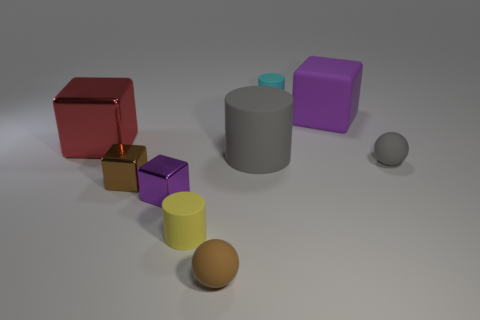There is a tiny cylinder to the left of the small cylinder that is behind the ball that is right of the purple matte object; what is its material?
Keep it short and to the point. Rubber. Is the number of yellow objects that are left of the yellow cylinder greater than the number of red blocks behind the tiny brown metallic block?
Provide a short and direct response. No. How many spheres are either big red objects or tiny cyan rubber objects?
Keep it short and to the point. 0. There is a matte sphere that is in front of the cylinder in front of the small gray rubber ball; how many small yellow matte cylinders are right of it?
Your response must be concise. 0. What is the material of the thing that is the same color as the large rubber cube?
Your answer should be very brief. Metal. Are there more small shiny objects than small brown rubber objects?
Keep it short and to the point. Yes. Is the size of the cyan cylinder the same as the purple shiny object?
Keep it short and to the point. Yes. How many objects are small brown matte things or cyan rubber things?
Keep it short and to the point. 2. What is the shape of the big thing that is left of the matte ball that is on the left side of the big thing that is behind the large red metallic thing?
Provide a succinct answer. Cube. Are the tiny cylinder on the left side of the brown ball and the block left of the small brown shiny cube made of the same material?
Keep it short and to the point. No. 